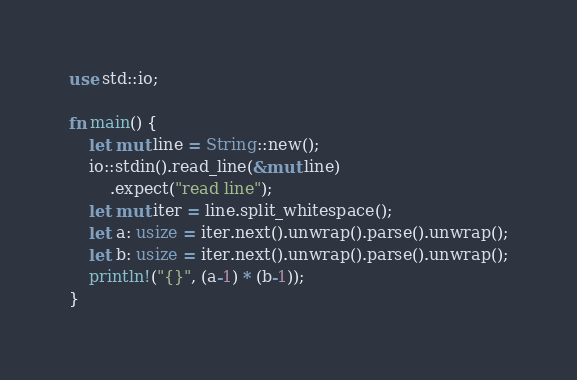<code> <loc_0><loc_0><loc_500><loc_500><_Rust_>use std::io;

fn main() {
    let mut line = String::new();
    io::stdin().read_line(&mut line)
        .expect("read line");
    let mut iter = line.split_whitespace();
    let a: usize = iter.next().unwrap().parse().unwrap();
    let b: usize = iter.next().unwrap().parse().unwrap();
    println!("{}", (a-1) * (b-1));
}</code> 